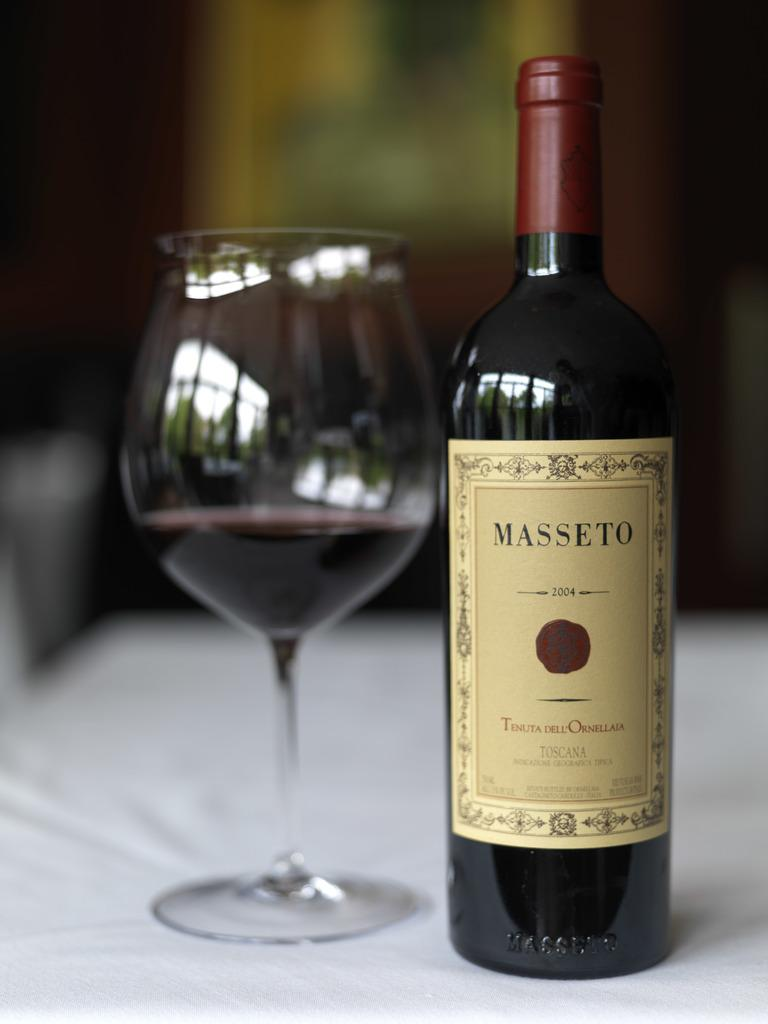<image>
Offer a succinct explanation of the picture presented. A bottle of Masseto Toscana is sitting on a table next to a wine glass. 